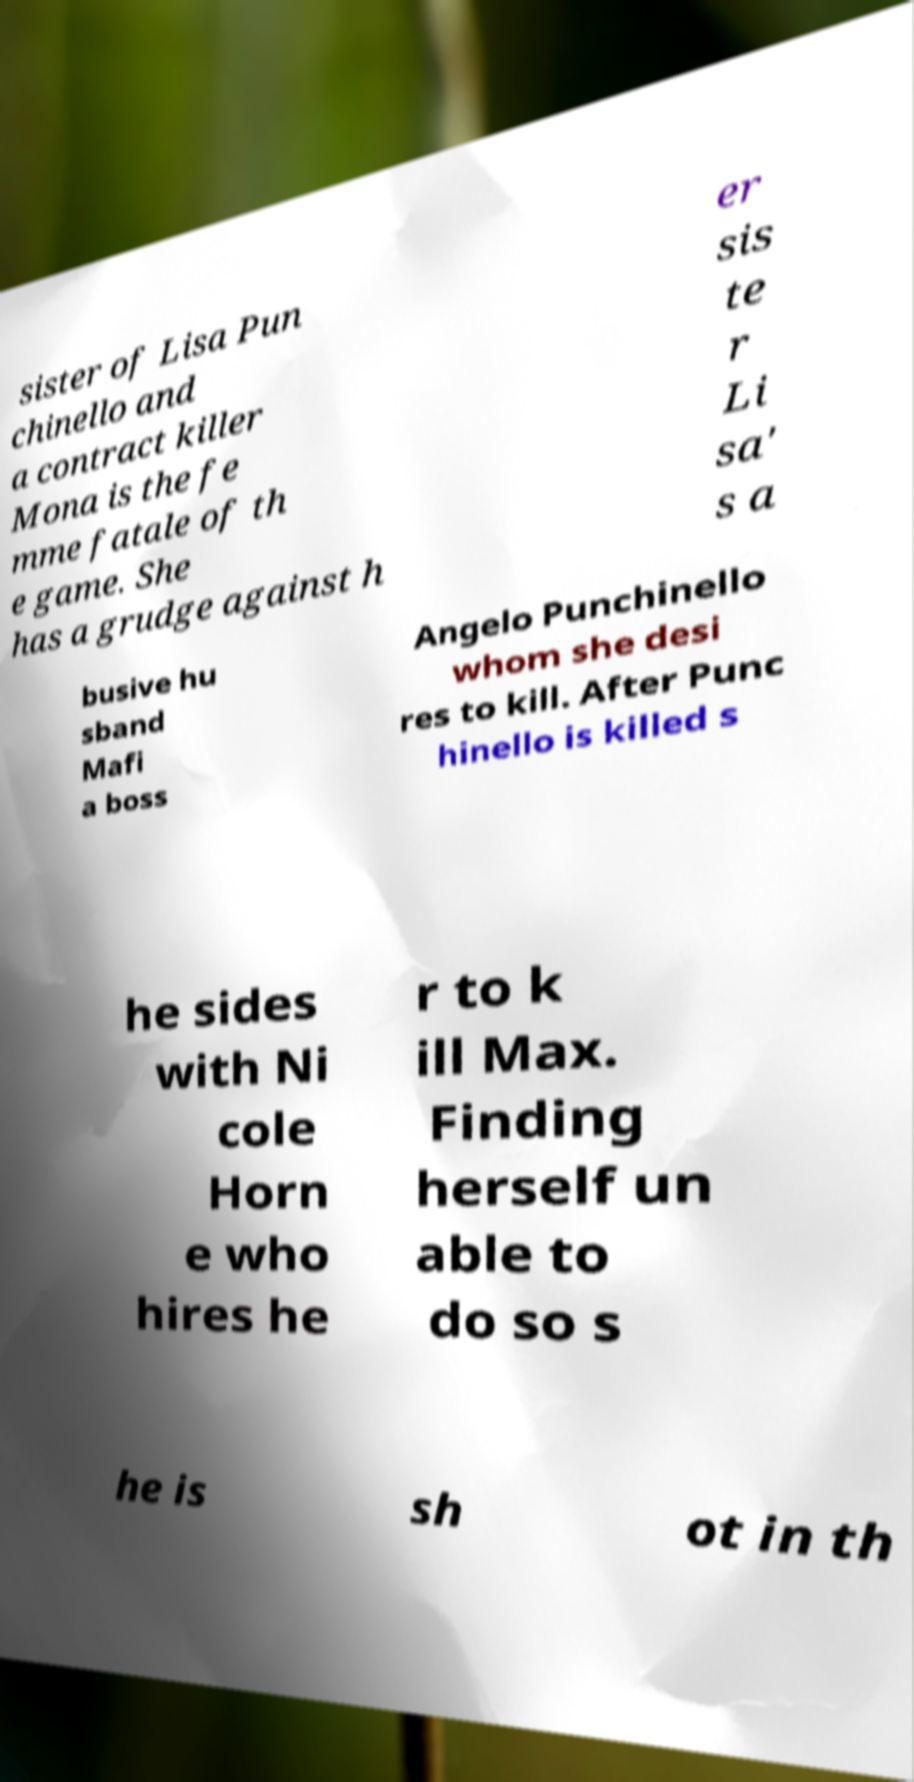I need the written content from this picture converted into text. Can you do that? sister of Lisa Pun chinello and a contract killer Mona is the fe mme fatale of th e game. She has a grudge against h er sis te r Li sa' s a busive hu sband Mafi a boss Angelo Punchinello whom she desi res to kill. After Punc hinello is killed s he sides with Ni cole Horn e who hires he r to k ill Max. Finding herself un able to do so s he is sh ot in th 